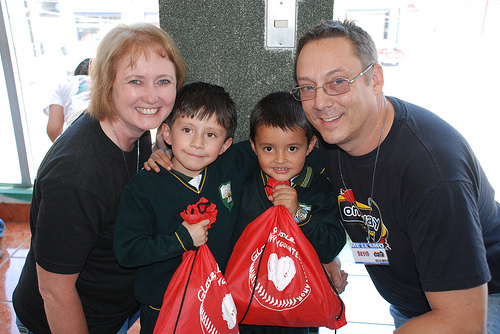<image>
Is there a bag on the bag? No. The bag is not positioned on the bag. They may be near each other, but the bag is not supported by or resting on top of the bag. 